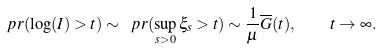<formula> <loc_0><loc_0><loc_500><loc_500>\ p r ( \log ( I ) > t ) \sim \ p r ( \sup _ { s > 0 } \xi _ { s } > t ) \sim \frac { 1 } { \mu } \overline { G } ( t ) , \quad t \to \infty .</formula> 